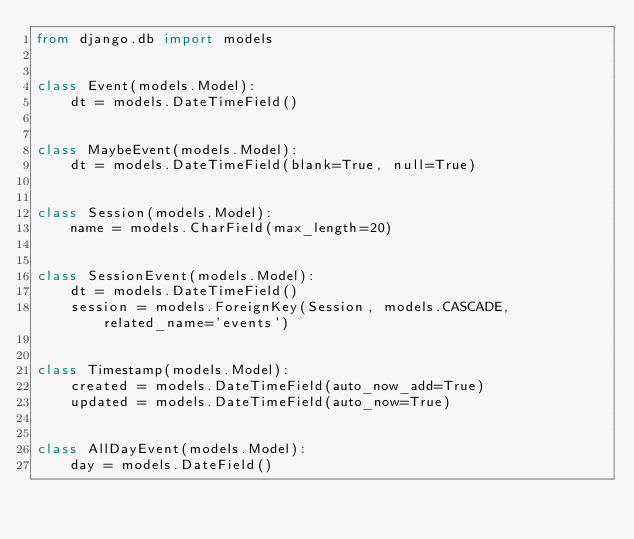Convert code to text. <code><loc_0><loc_0><loc_500><loc_500><_Python_>from django.db import models


class Event(models.Model):
    dt = models.DateTimeField()


class MaybeEvent(models.Model):
    dt = models.DateTimeField(blank=True, null=True)


class Session(models.Model):
    name = models.CharField(max_length=20)


class SessionEvent(models.Model):
    dt = models.DateTimeField()
    session = models.ForeignKey(Session, models.CASCADE, related_name='events')


class Timestamp(models.Model):
    created = models.DateTimeField(auto_now_add=True)
    updated = models.DateTimeField(auto_now=True)


class AllDayEvent(models.Model):
    day = models.DateField()
</code> 